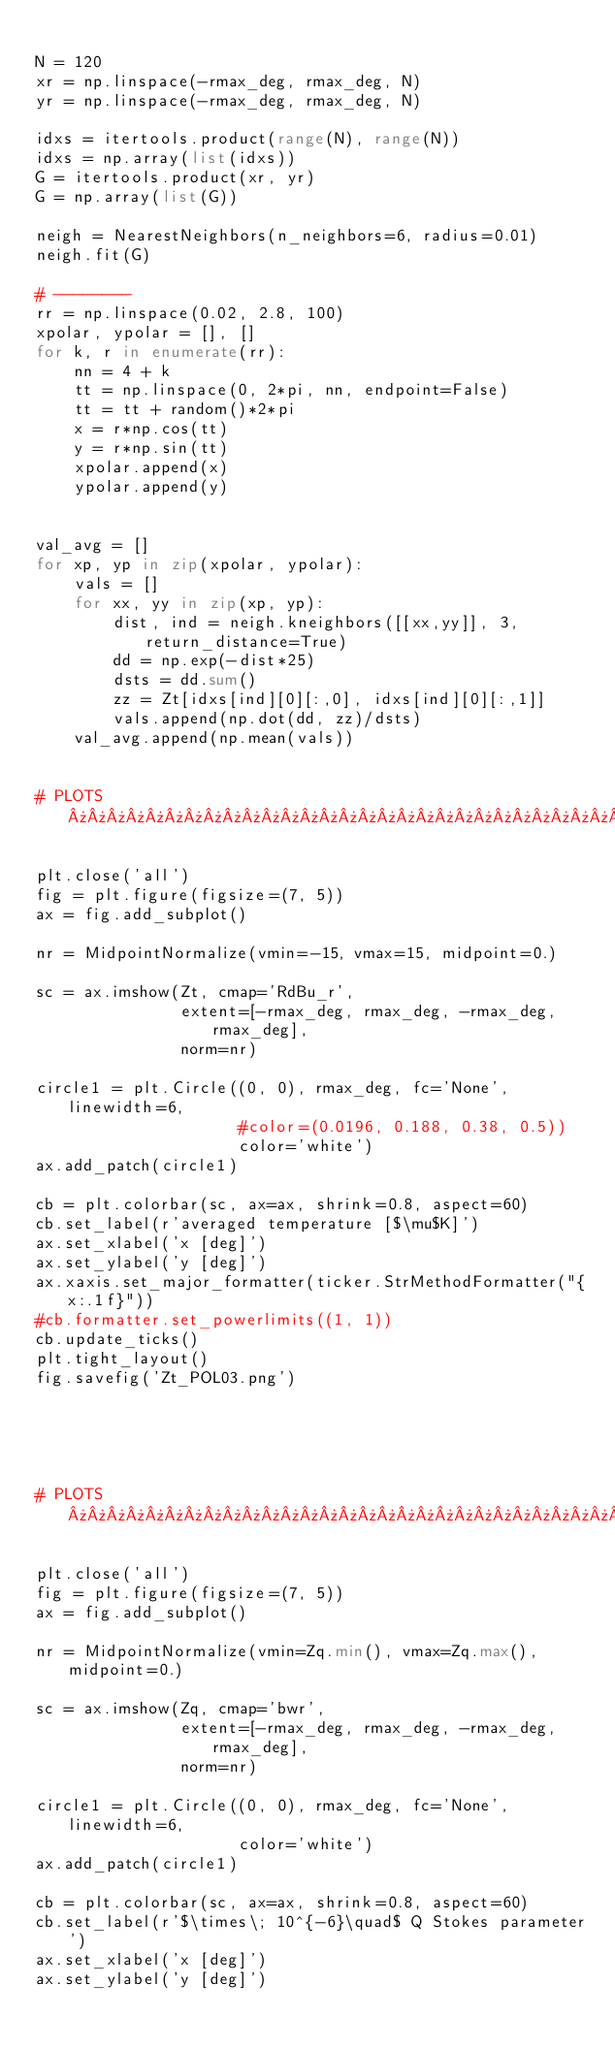<code> <loc_0><loc_0><loc_500><loc_500><_Python_>
N = 120
xr = np.linspace(-rmax_deg, rmax_deg, N)
yr = np.linspace(-rmax_deg, rmax_deg, N)

idxs = itertools.product(range(N), range(N))
idxs = np.array(list(idxs))
G = itertools.product(xr, yr)
G = np.array(list(G))

neigh = NearestNeighbors(n_neighbors=6, radius=0.01)
neigh.fit(G)

# -------- 
rr = np.linspace(0.02, 2.8, 100)
xpolar, ypolar = [], []
for k, r in enumerate(rr):
    nn = 4 + k    
    tt = np.linspace(0, 2*pi, nn, endpoint=False)
    tt = tt + random()*2*pi
    x = r*np.cos(tt)
    y = r*np.sin(tt)
    xpolar.append(x)
    ypolar.append(y)


val_avg = []
for xp, yp in zip(xpolar, ypolar):
    vals = []
    for xx, yy in zip(xp, yp):
        dist, ind = neigh.kneighbors([[xx,yy]], 3, return_distance=True)
        dd = np.exp(-dist*25)
        dsts = dd.sum()
        zz = Zt[idxs[ind][0][:,0], idxs[ind][0][:,1]]
        vals.append(np.dot(dd, zz)/dsts)
    val_avg.append(np.mean(vals))  


# PLOTS »»»»»»»»»»»»»»»»»»»»»»»»»»»»»»»»»»»»»»

plt.close('all')
fig = plt.figure(figsize=(7, 5))
ax = fig.add_subplot()

nr = MidpointNormalize(vmin=-15, vmax=15, midpoint=0.)

sc = ax.imshow(Zt, cmap='RdBu_r',
               extent=[-rmax_deg, rmax_deg, -rmax_deg, rmax_deg],
               norm=nr)

circle1 = plt.Circle((0, 0), rmax_deg, fc='None', linewidth=6,
                     #color=(0.0196, 0.188, 0.38, 0.5))
                     color='white')
ax.add_patch(circle1)

cb = plt.colorbar(sc, ax=ax, shrink=0.8, aspect=60)
cb.set_label(r'averaged temperature [$\mu$K]')
ax.set_xlabel('x [deg]')
ax.set_ylabel('y [deg]')
ax.xaxis.set_major_formatter(ticker.StrMethodFormatter("{x:.1f}"))
#cb.formatter.set_powerlimits((1, 1))
cb.update_ticks()
plt.tight_layout()
fig.savefig('Zt_POL03.png')   





# PLOTS »»»»»»»»»»»»»»»»»»»»»»»»»»»»»»»»»»»»»»

plt.close('all')
fig = plt.figure(figsize=(7, 5))
ax = fig.add_subplot()

nr = MidpointNormalize(vmin=Zq.min(), vmax=Zq.max(), midpoint=0.)

sc = ax.imshow(Zq, cmap='bwr',
               extent=[-rmax_deg, rmax_deg, -rmax_deg, rmax_deg],
               norm=nr)

circle1 = plt.Circle((0, 0), rmax_deg, fc='None', linewidth=6,
                     color='white')
ax.add_patch(circle1)

cb = plt.colorbar(sc, ax=ax, shrink=0.8, aspect=60)
cb.set_label(r'$\times\; 10^{-6}\quad$ Q Stokes parameter')
ax.set_xlabel('x [deg]')
ax.set_ylabel('y [deg]')</code> 